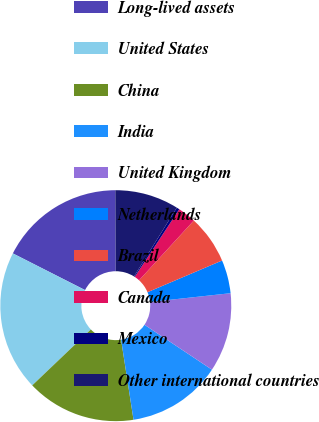<chart> <loc_0><loc_0><loc_500><loc_500><pie_chart><fcel>Long-lived assets<fcel>United States<fcel>China<fcel>India<fcel>United Kingdom<fcel>Netherlands<fcel>Brazil<fcel>Canada<fcel>Mexico<fcel>Other international countries<nl><fcel>17.46%<fcel>19.6%<fcel>15.33%<fcel>13.2%<fcel>11.07%<fcel>4.67%<fcel>6.8%<fcel>2.54%<fcel>0.4%<fcel>8.93%<nl></chart> 